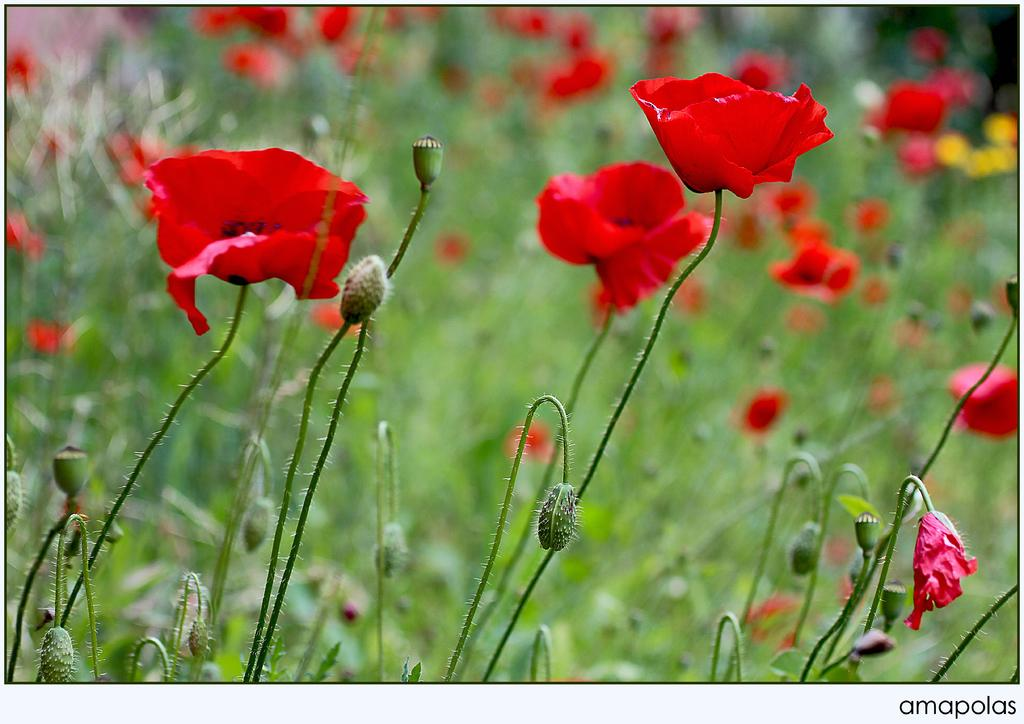What is the main subject of the image? The main subject of the image is flowers and buds on stems. Can you describe the background of the image? The background of the image is blurred. Is there any text present in the image? Yes, there is some text at the bottom right side of the image. How does the police officer's haircut look in the image? There is no police officer or haircut present in the image. What emotion is the person feeling in the image? There is no person or indication of emotion in the image; it features flowers and buds on stems. 